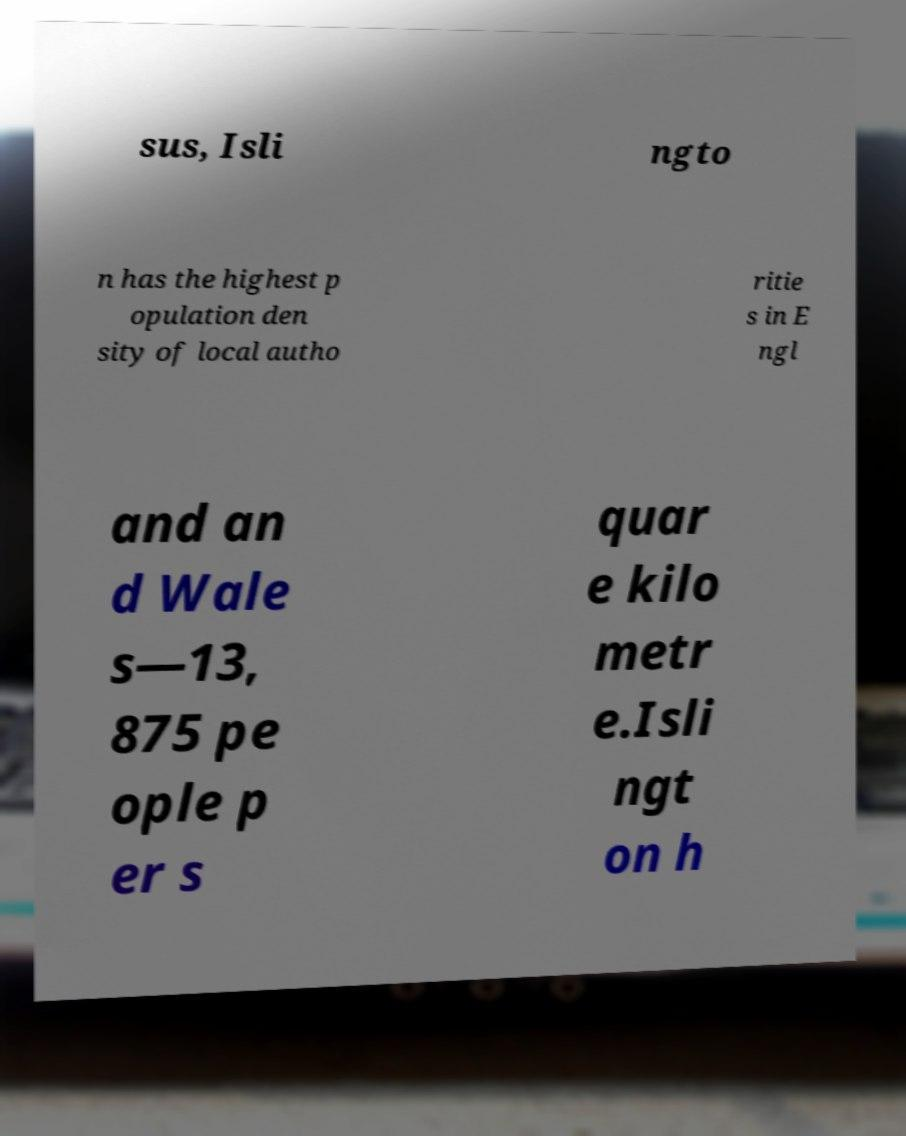What messages or text are displayed in this image? I need them in a readable, typed format. sus, Isli ngto n has the highest p opulation den sity of local autho ritie s in E ngl and an d Wale s—13, 875 pe ople p er s quar e kilo metr e.Isli ngt on h 